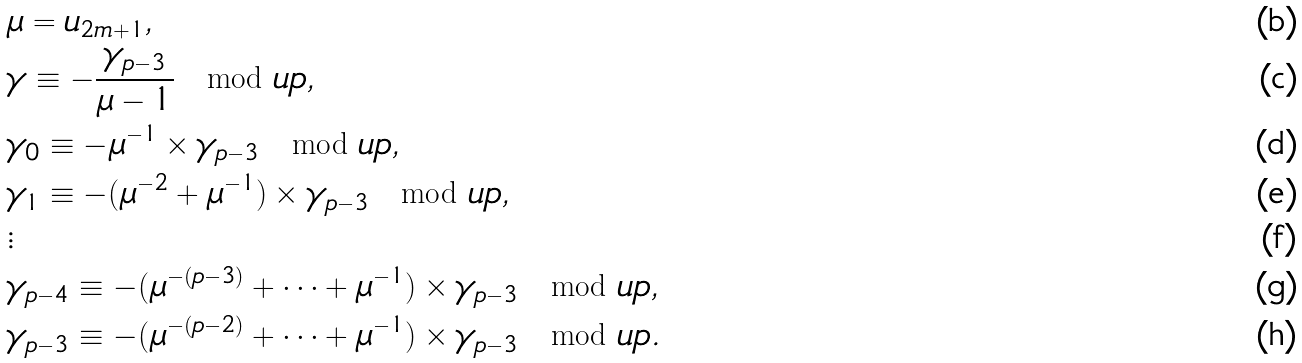<formula> <loc_0><loc_0><loc_500><loc_500>& \mu = u _ { 2 m + 1 } , \\ & \gamma \equiv - \frac { \gamma _ { p - 3 } } { \mu - 1 } \mod u p , \\ & \gamma _ { 0 } \equiv - \mu ^ { - 1 } \times \gamma _ { p - 3 } \mod u p , \\ & \gamma _ { 1 } \equiv - ( \mu ^ { - 2 } + \mu ^ { - 1 } ) \times \gamma _ { p - 3 } \mod u p , \\ & \vdots \\ & \gamma _ { p - 4 } \equiv - ( \mu ^ { - ( p - 3 ) } + \dots + \mu ^ { - 1 } ) \times \gamma _ { p - 3 } \mod u p , \\ & \gamma _ { p - 3 } \equiv - ( \mu ^ { - ( p - 2 ) } + \dots + \mu ^ { - 1 } ) \times \gamma _ { p - 3 } \mod u p .</formula> 